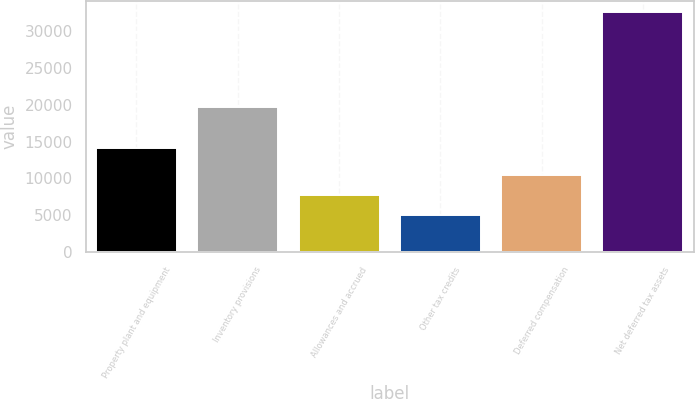<chart> <loc_0><loc_0><loc_500><loc_500><bar_chart><fcel>Property plant and equipment<fcel>Inventory provisions<fcel>Allowances and accrued<fcel>Other tax credits<fcel>Deferred compensation<fcel>Net deferred tax assets<nl><fcel>14122<fcel>19710<fcel>7773<fcel>5027<fcel>10519<fcel>32487<nl></chart> 